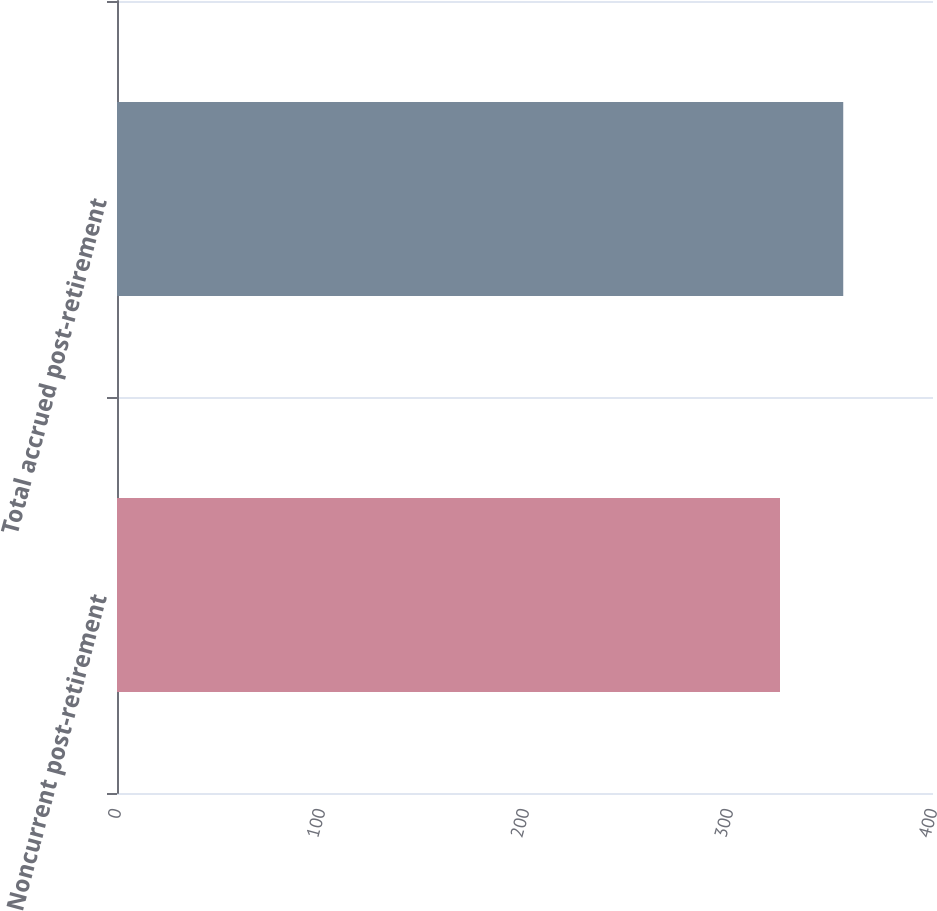<chart> <loc_0><loc_0><loc_500><loc_500><bar_chart><fcel>Noncurrent post-retirement<fcel>Total accrued post-retirement<nl><fcel>325<fcel>356<nl></chart> 